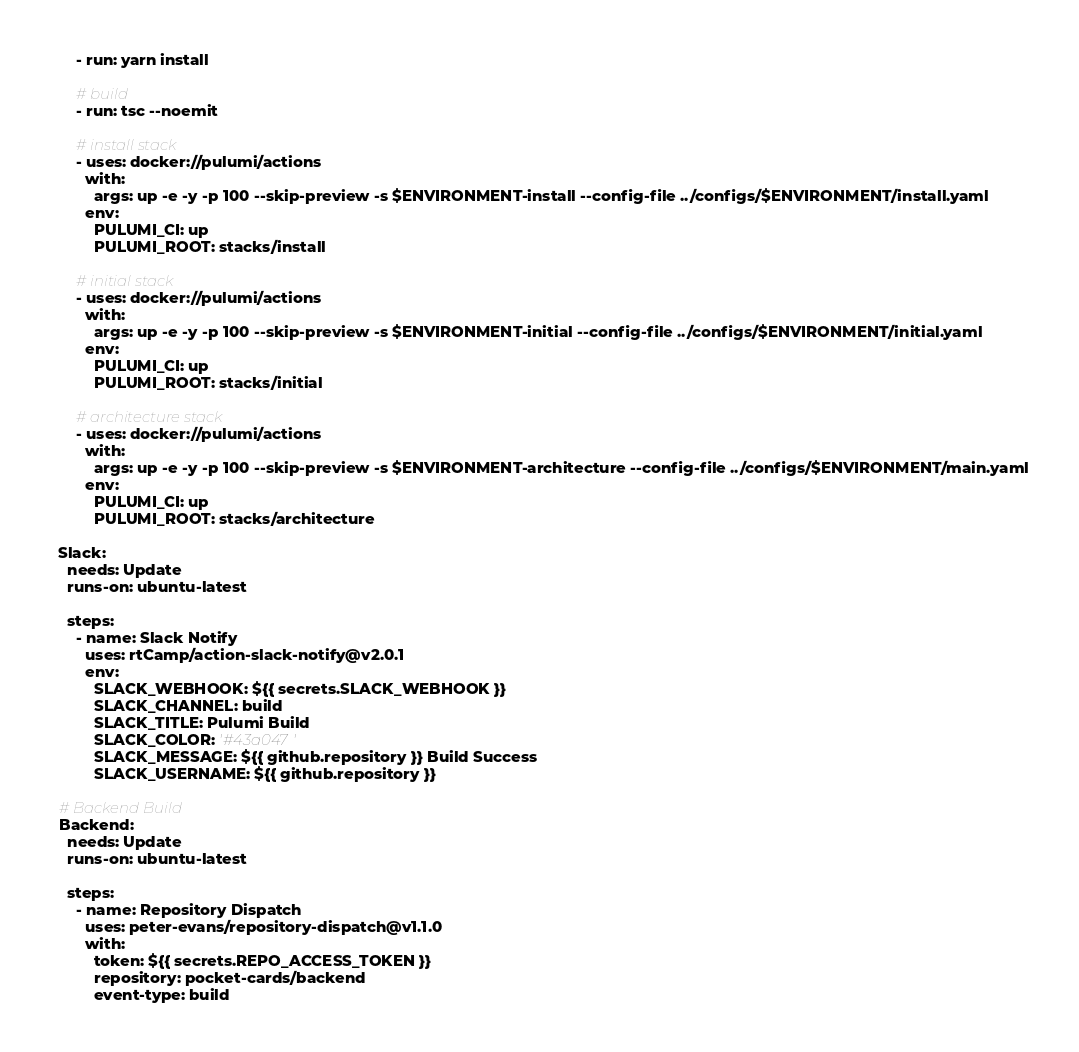<code> <loc_0><loc_0><loc_500><loc_500><_YAML_>      - run: yarn install

      # build
      - run: tsc --noemit

      # install stack
      - uses: docker://pulumi/actions
        with:
          args: up -e -y -p 100 --skip-preview -s $ENVIRONMENT-install --config-file ../configs/$ENVIRONMENT/install.yaml
        env:
          PULUMI_CI: up
          PULUMI_ROOT: stacks/install

      # initial stack
      - uses: docker://pulumi/actions
        with:
          args: up -e -y -p 100 --skip-preview -s $ENVIRONMENT-initial --config-file ../configs/$ENVIRONMENT/initial.yaml
        env:
          PULUMI_CI: up
          PULUMI_ROOT: stacks/initial

      # architecture stack
      - uses: docker://pulumi/actions
        with:
          args: up -e -y -p 100 --skip-preview -s $ENVIRONMENT-architecture --config-file ../configs/$ENVIRONMENT/main.yaml
        env:
          PULUMI_CI: up
          PULUMI_ROOT: stacks/architecture

  Slack:
    needs: Update
    runs-on: ubuntu-latest

    steps:
      - name: Slack Notify
        uses: rtCamp/action-slack-notify@v2.0.1
        env:
          SLACK_WEBHOOK: ${{ secrets.SLACK_WEBHOOK }}
          SLACK_CHANNEL: build
          SLACK_TITLE: Pulumi Build
          SLACK_COLOR: '#43a047'
          SLACK_MESSAGE: ${{ github.repository }} Build Success
          SLACK_USERNAME: ${{ github.repository }}

  # Backend Build
  Backend:
    needs: Update
    runs-on: ubuntu-latest

    steps:
      - name: Repository Dispatch
        uses: peter-evans/repository-dispatch@v1.1.0
        with:
          token: ${{ secrets.REPO_ACCESS_TOKEN }}
          repository: pocket-cards/backend
          event-type: build
</code> 